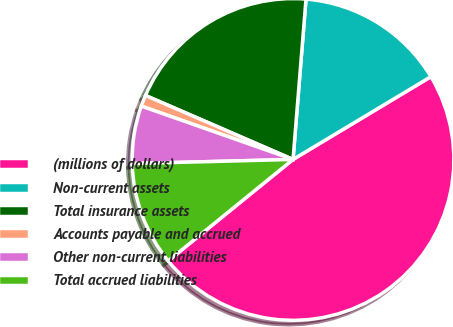<chart> <loc_0><loc_0><loc_500><loc_500><pie_chart><fcel>(millions of dollars)<fcel>Non-current assets<fcel>Total insurance assets<fcel>Accounts payable and accrued<fcel>Other non-current liabilities<fcel>Total accrued liabilities<nl><fcel>47.74%<fcel>15.11%<fcel>19.77%<fcel>1.13%<fcel>5.79%<fcel>10.45%<nl></chart> 